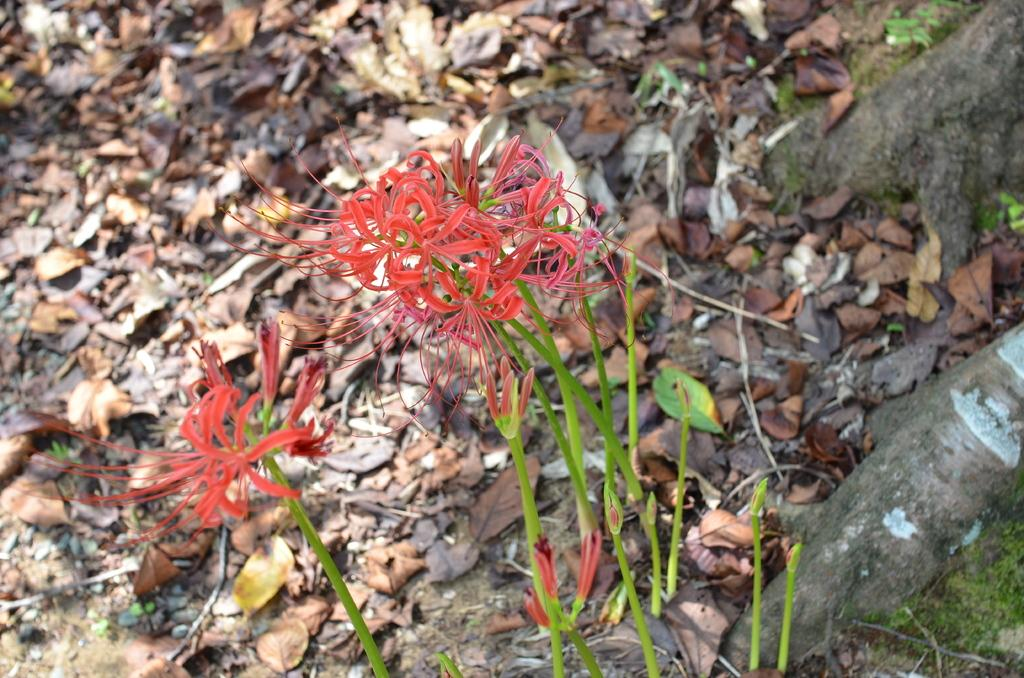What is covering the land in the image? The land is covered with dried leaves in the image. What type of plants can be seen in the image? There are plants with flowers in the image. Where is the desk located in the image? There is no desk present in the image. Can you see a cat in the image? There is no cat present in the image. 